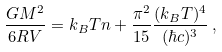<formula> <loc_0><loc_0><loc_500><loc_500>\frac { G M ^ { 2 } } { 6 R V } = k _ { B } T n + \frac { \pi ^ { 2 } } { 1 5 } \frac { ( k _ { B } T ) ^ { 4 } } { ( \hbar { c } ) ^ { 3 } } \, ,</formula> 